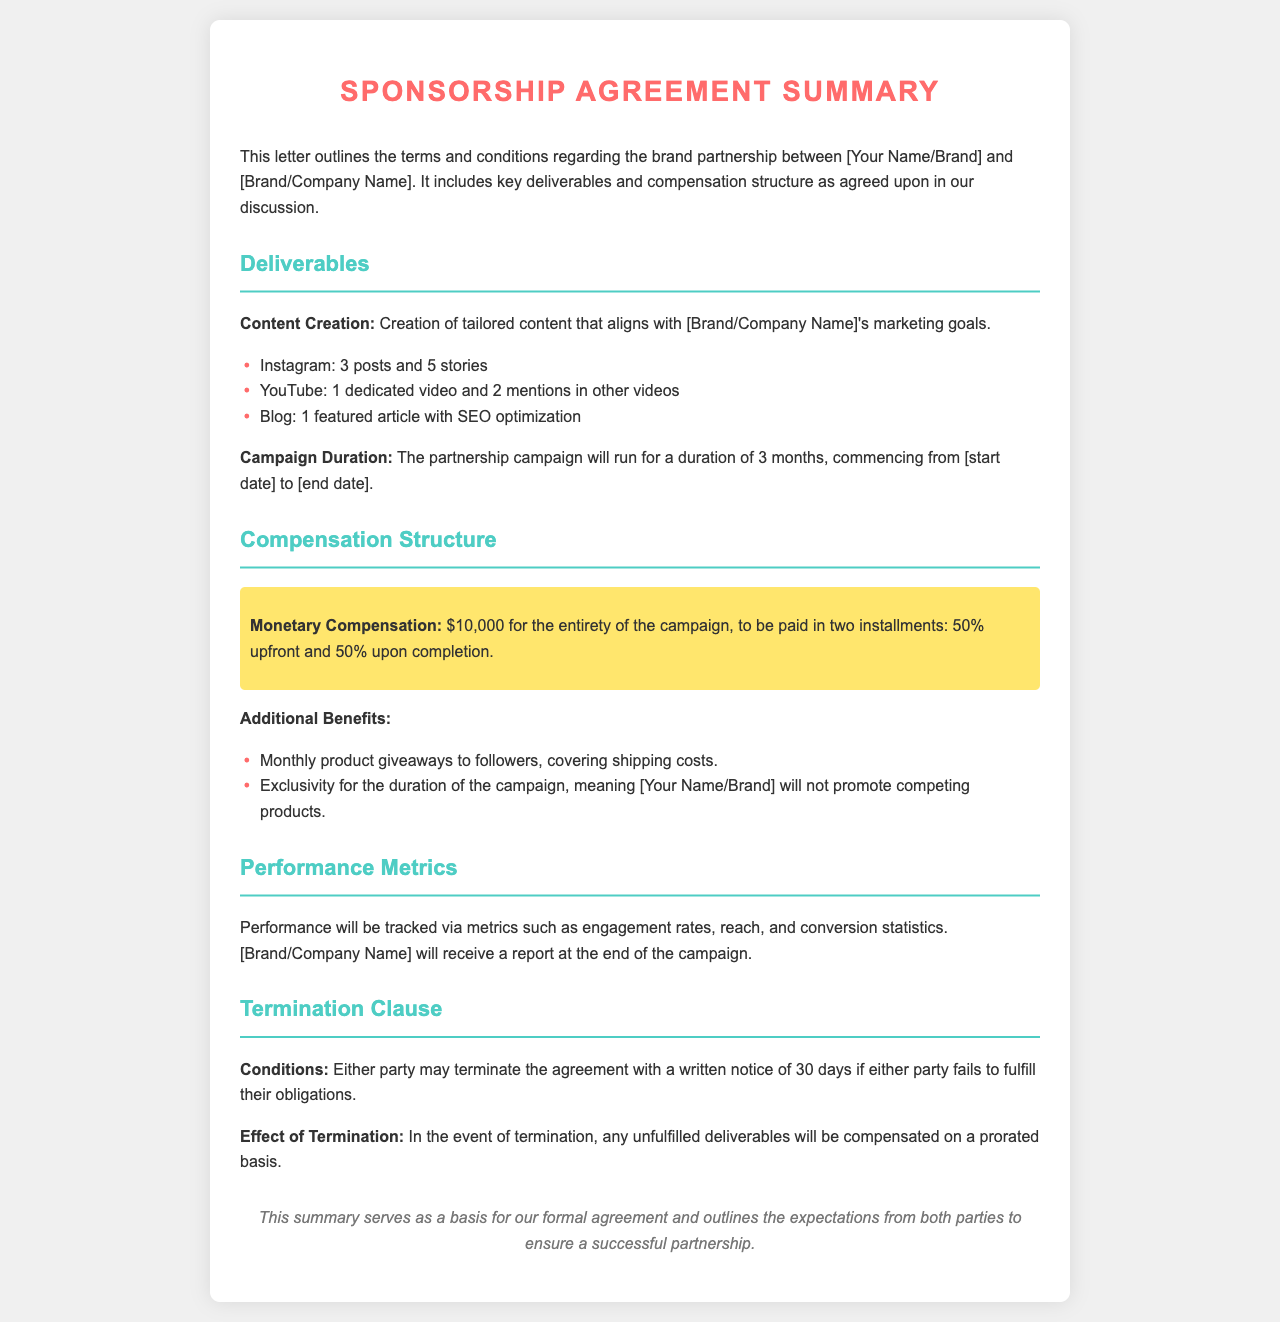What are the three types of deliverables? The document lists the types of deliverables under "Deliverables," specifically focused on content creation.
Answer: Instagram, YouTube, Blog What is the total monetary compensation? The document specifies the total monetary compensation for the campaign mentioned under "Compensation Structure."
Answer: $10,000 What percentage of the compensation is paid upfront? The document indicates the payment structure, specifically the percentage to be paid upfront in the "Compensation Structure."
Answer: 50% For how long will the campaign run? The campaign duration is clearly stated in the "Deliverables" section, detailing the time frame of the campaign.
Answer: 3 months What must be given as a notice period for termination? The document outlines the termination clause, specifically the notice period required for either party to terminate the agreement.
Answer: 30 days What will be included in the final report to the brand? The document mentions performance metrics that will be reported to the brand at the end of the campaign under "Performance Metrics."
Answer: engagement rates, reach, and conversion statistics What clause ensures that no competing products are promoted? The document discusses exclusivity during the campaign, highlighting a specific clause in the "Additional Benefits" section.
Answer: Exclusivity How many Instagram stories are required? The specific deliverable related to Instagram is mentioned in the "Deliverables" section, listing the number of stories.
Answer: 5 stories 